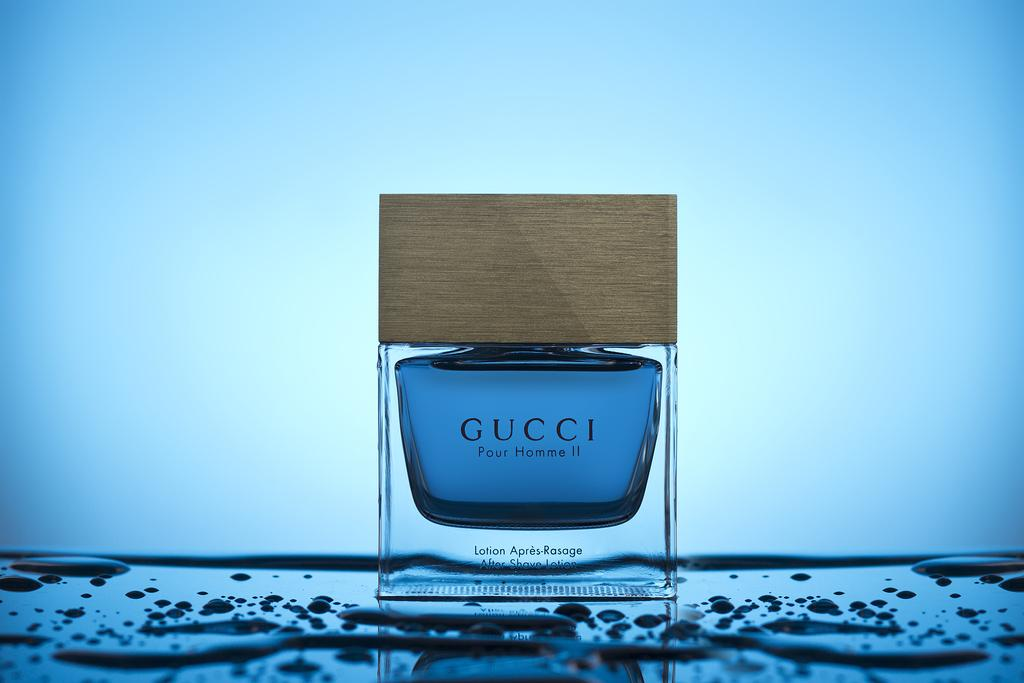<image>
Offer a succinct explanation of the picture presented. A bottle of Gucci Pour Homme II is displayed on a wet surface. 